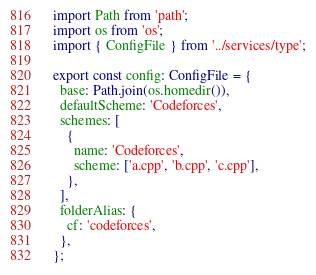Convert code to text. <code><loc_0><loc_0><loc_500><loc_500><_TypeScript_>import Path from 'path';
import os from 'os';
import { ConfigFile } from '../services/type';

export const config: ConfigFile = {
  base: Path.join(os.homedir()),
  defaultScheme: 'Codeforces',
  schemes: [
    {
      name: 'Codeforces',
      scheme: ['a.cpp', 'b.cpp', 'c.cpp'],
    },
  ],
  folderAlias: {
    cf: 'codeforces',
  },
};
</code> 